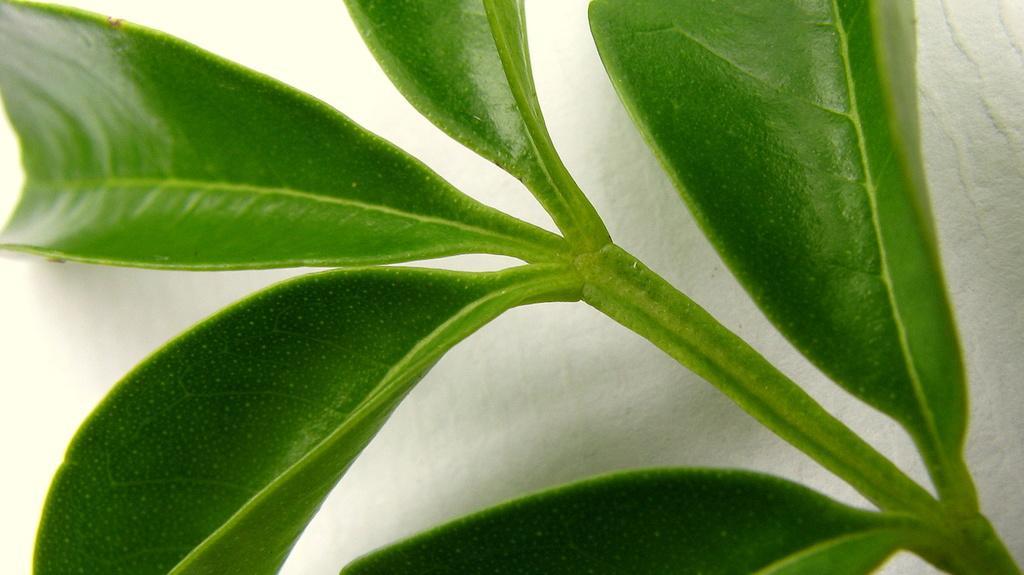How would you summarize this image in a sentence or two? In this image there are leaves. The background is white. 